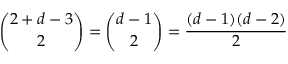<formula> <loc_0><loc_0><loc_500><loc_500>{ \binom { 2 + d - 3 } { 2 } } = { \binom { d - 1 } { 2 } } = { \frac { ( d - 1 ) ( d - 2 ) } { 2 } }</formula> 